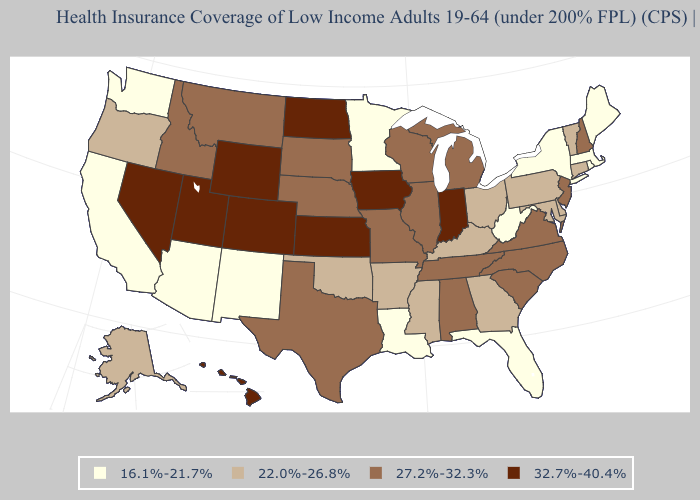Does Vermont have the same value as North Carolina?
Short answer required. No. Name the states that have a value in the range 22.0%-26.8%?
Answer briefly. Alaska, Arkansas, Connecticut, Delaware, Georgia, Kentucky, Maryland, Mississippi, Ohio, Oklahoma, Oregon, Pennsylvania, Vermont. Does the map have missing data?
Give a very brief answer. No. Name the states that have a value in the range 22.0%-26.8%?
Short answer required. Alaska, Arkansas, Connecticut, Delaware, Georgia, Kentucky, Maryland, Mississippi, Ohio, Oklahoma, Oregon, Pennsylvania, Vermont. Is the legend a continuous bar?
Answer briefly. No. Does Tennessee have a lower value than Indiana?
Be succinct. Yes. Does the map have missing data?
Be succinct. No. Name the states that have a value in the range 22.0%-26.8%?
Keep it brief. Alaska, Arkansas, Connecticut, Delaware, Georgia, Kentucky, Maryland, Mississippi, Ohio, Oklahoma, Oregon, Pennsylvania, Vermont. Does the map have missing data?
Short answer required. No. Among the states that border Arkansas , which have the highest value?
Concise answer only. Missouri, Tennessee, Texas. What is the value of Minnesota?
Short answer required. 16.1%-21.7%. How many symbols are there in the legend?
Keep it brief. 4. Name the states that have a value in the range 22.0%-26.8%?
Give a very brief answer. Alaska, Arkansas, Connecticut, Delaware, Georgia, Kentucky, Maryland, Mississippi, Ohio, Oklahoma, Oregon, Pennsylvania, Vermont. Does the first symbol in the legend represent the smallest category?
Quick response, please. Yes. Which states hav the highest value in the South?
Give a very brief answer. Alabama, North Carolina, South Carolina, Tennessee, Texas, Virginia. 